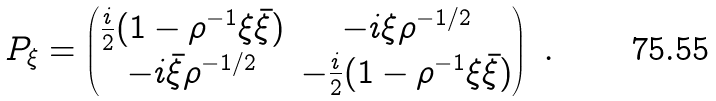Convert formula to latex. <formula><loc_0><loc_0><loc_500><loc_500>P _ { \xi } = \begin{pmatrix} \frac { i } { 2 } ( 1 - \rho ^ { - 1 } \xi \bar { \xi } ) & - i \xi \rho ^ { - 1 / 2 } \\ - i \bar { \xi } \rho ^ { - 1 / 2 } & - \frac { i } { 2 } ( 1 - \rho ^ { - 1 } \xi \bar { \xi } ) \end{pmatrix} \ .</formula> 